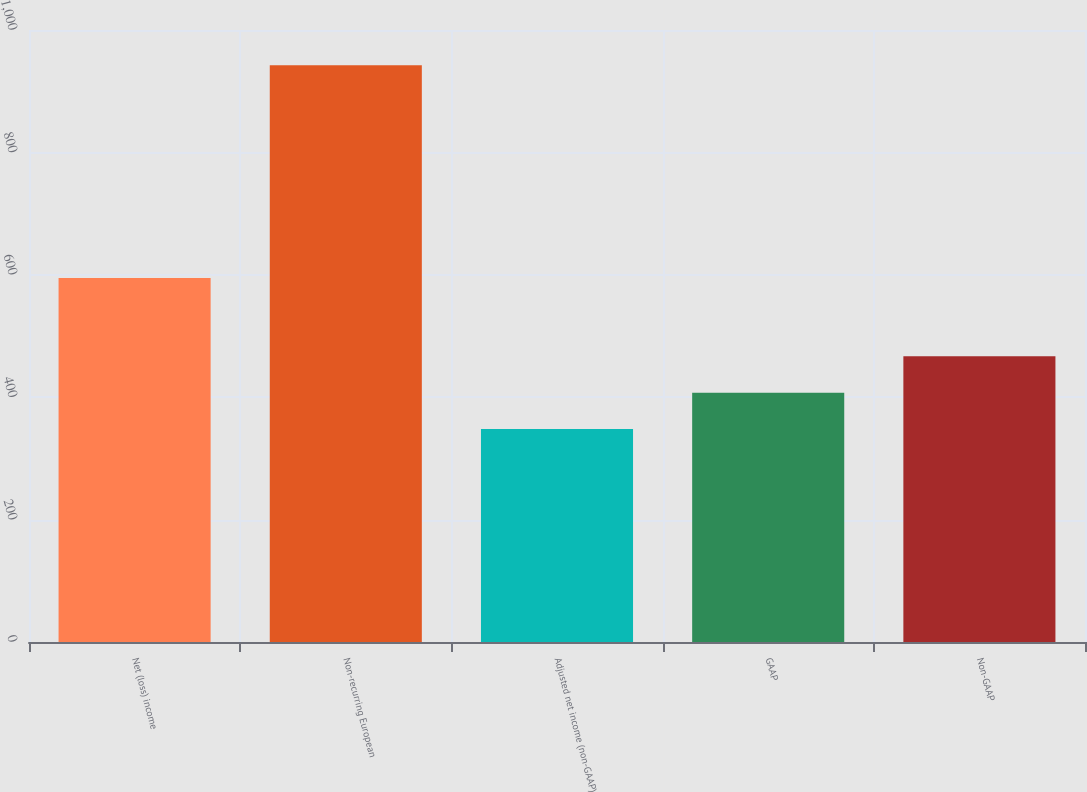<chart> <loc_0><loc_0><loc_500><loc_500><bar_chart><fcel>Net (loss) income<fcel>Non-recurring European<fcel>Adjusted net income (non-GAAP)<fcel>GAAP<fcel>Non-GAAP<nl><fcel>594.6<fcel>942.6<fcel>348<fcel>407.46<fcel>466.92<nl></chart> 